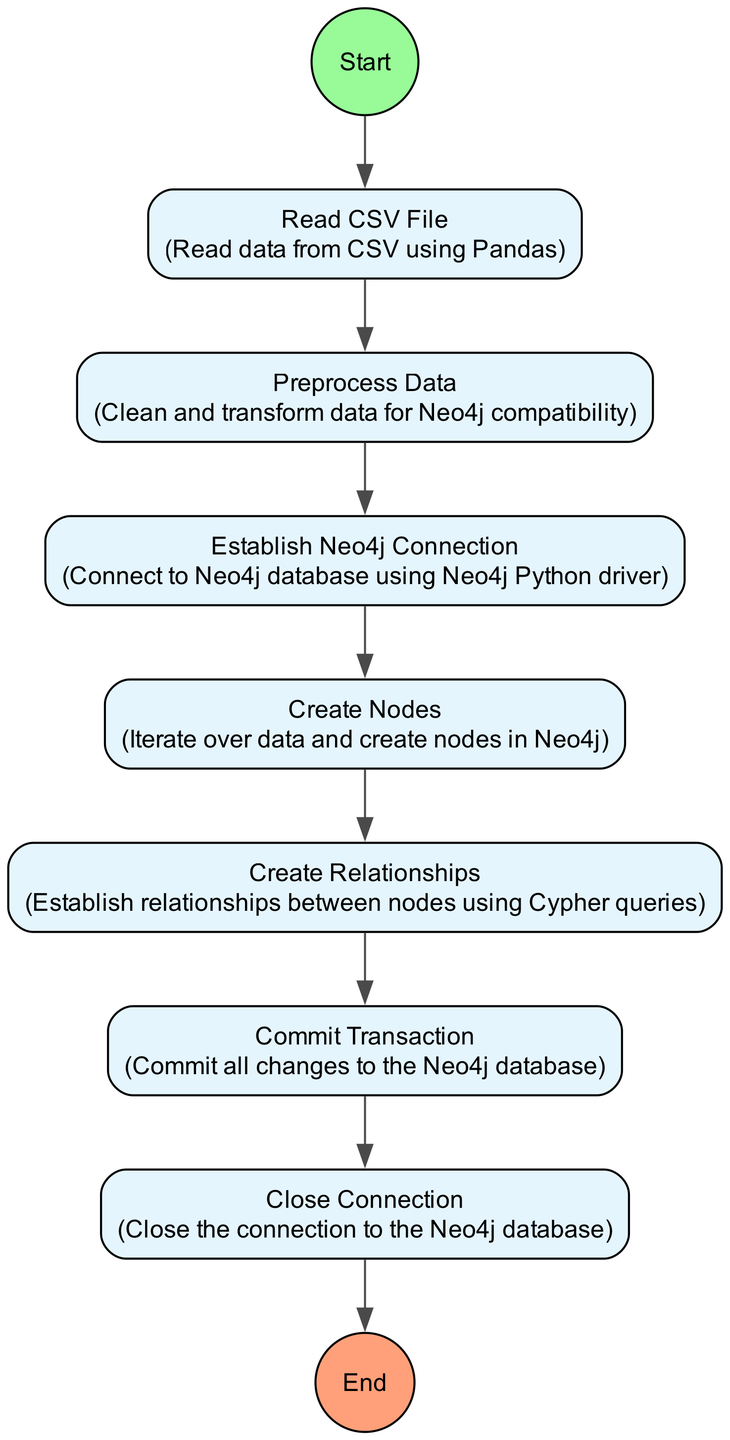What is the first activity in the diagram? The diagram starts with the "Start" node, indicating the beginning of the data loading process.
Answer: Start How many activities are there in the diagram? Upon counting, there are a total of seven activities listed: "Read CSV File," "Preprocess Data," "Establish Neo4j Connection," "Create Nodes," "Create Relationships," "Commit Transaction," and "Close Connection."
Answer: Seven What is the last activity before ending the process? The last activity before the "End" is "Close Connection," marking the final step in the data loading pipeline.
Answer: Close Connection Which activity follows "Preprocess Data"? The activity that follows "Preprocess Data" is "Establish Neo4j Connection," which indicates the next step in the flow.
Answer: Establish Neo4j Connection What relationship exists between "Create Nodes" and "Create Relationships"? The relationship indicates that "Create Relationships" follows "Create Nodes," showing that nodes are created prior to establishing their relationships.
Answer: Follow Which activity is responsible for committing changes to the database? The activity designated for committing changes is "Commit Transaction," ensuring that all modifications made to the Neo4j database are saved.
Answer: Commit Transaction Why is "Establish Neo4j Connection" important in the pipeline? "Establish Neo4j Connection" is crucial as it allows the data loading pipeline to connect to the Neo4j database, enabling further operations like creating nodes and relationships.
Answer: Important How do the activities flow from the start to the end of the diagram? The activities flow from "Start" to "Read CSV File," then to "Preprocess Data," followed by "Establish Neo4j Connection," leading to "Create Nodes," then "Create Relationships," and finally to "Commit Transaction," "Close Connection," and end with "End." This sequence describes the complete data loading process in order.
Answer: Sequentially 